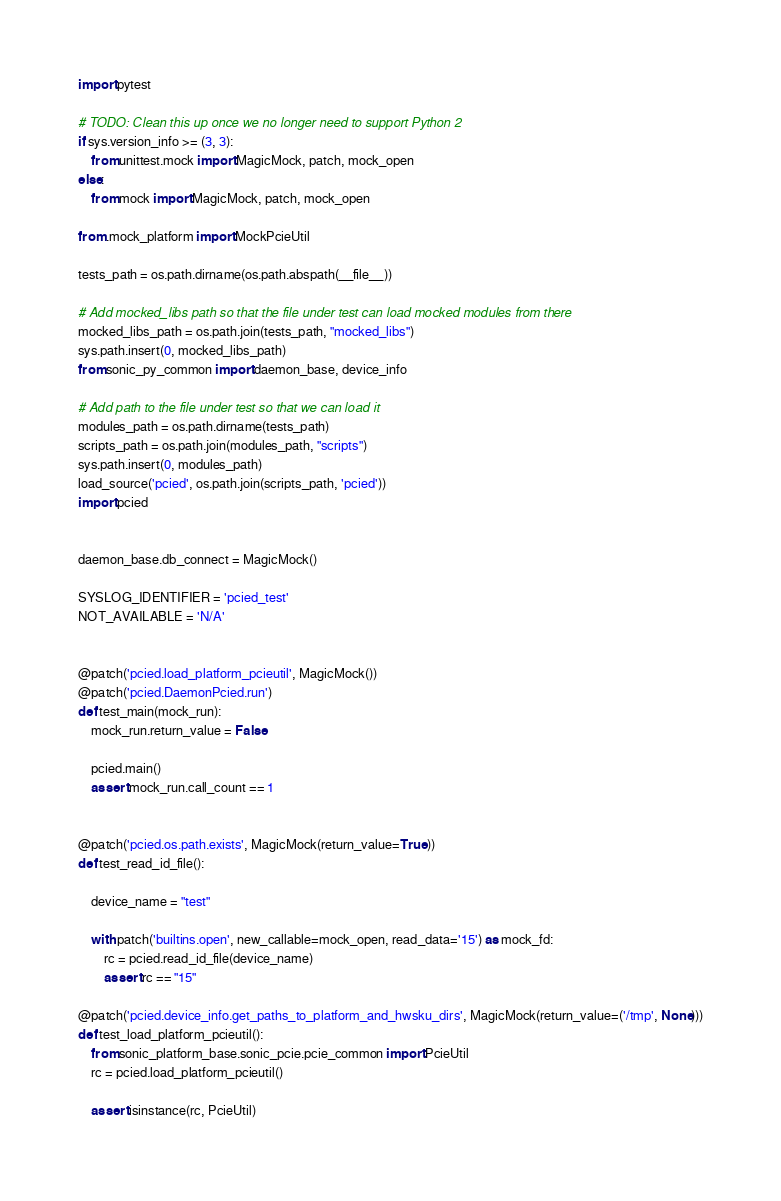Convert code to text. <code><loc_0><loc_0><loc_500><loc_500><_Python_>import pytest

# TODO: Clean this up once we no longer need to support Python 2
if sys.version_info >= (3, 3):
    from unittest.mock import MagicMock, patch, mock_open
else:
    from mock import MagicMock, patch, mock_open

from .mock_platform import MockPcieUtil

tests_path = os.path.dirname(os.path.abspath(__file__))

# Add mocked_libs path so that the file under test can load mocked modules from there
mocked_libs_path = os.path.join(tests_path, "mocked_libs")
sys.path.insert(0, mocked_libs_path)
from sonic_py_common import daemon_base, device_info

# Add path to the file under test so that we can load it
modules_path = os.path.dirname(tests_path)
scripts_path = os.path.join(modules_path, "scripts")
sys.path.insert(0, modules_path)
load_source('pcied', os.path.join(scripts_path, 'pcied'))
import pcied


daemon_base.db_connect = MagicMock()

SYSLOG_IDENTIFIER = 'pcied_test'
NOT_AVAILABLE = 'N/A'


@patch('pcied.load_platform_pcieutil', MagicMock())
@patch('pcied.DaemonPcied.run')
def test_main(mock_run):
    mock_run.return_value = False

    pcied.main()
    assert mock_run.call_count == 1


@patch('pcied.os.path.exists', MagicMock(return_value=True))
def test_read_id_file():

    device_name = "test"

    with patch('builtins.open', new_callable=mock_open, read_data='15') as mock_fd:
        rc = pcied.read_id_file(device_name)
        assert rc == "15"

@patch('pcied.device_info.get_paths_to_platform_and_hwsku_dirs', MagicMock(return_value=('/tmp', None)))
def test_load_platform_pcieutil():
    from sonic_platform_base.sonic_pcie.pcie_common import PcieUtil
    rc = pcied.load_platform_pcieutil()

    assert isinstance(rc, PcieUtil)</code> 